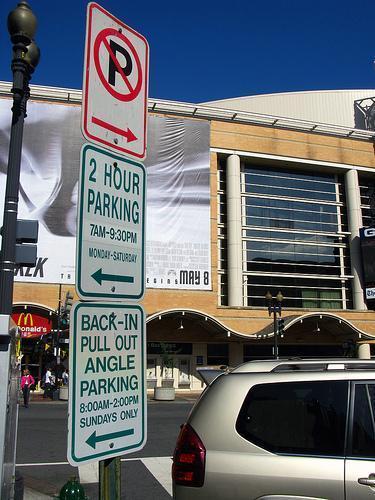How many signs are in the foreground?
Give a very brief answer. 3. 